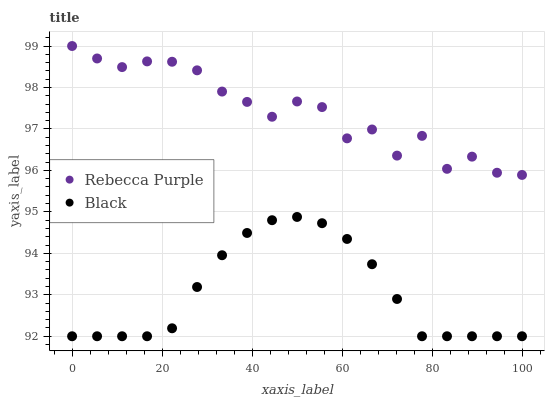Does Black have the minimum area under the curve?
Answer yes or no. Yes. Does Rebecca Purple have the maximum area under the curve?
Answer yes or no. Yes. Does Rebecca Purple have the minimum area under the curve?
Answer yes or no. No. Is Black the smoothest?
Answer yes or no. Yes. Is Rebecca Purple the roughest?
Answer yes or no. Yes. Is Rebecca Purple the smoothest?
Answer yes or no. No. Does Black have the lowest value?
Answer yes or no. Yes. Does Rebecca Purple have the lowest value?
Answer yes or no. No. Does Rebecca Purple have the highest value?
Answer yes or no. Yes. Is Black less than Rebecca Purple?
Answer yes or no. Yes. Is Rebecca Purple greater than Black?
Answer yes or no. Yes. Does Black intersect Rebecca Purple?
Answer yes or no. No. 